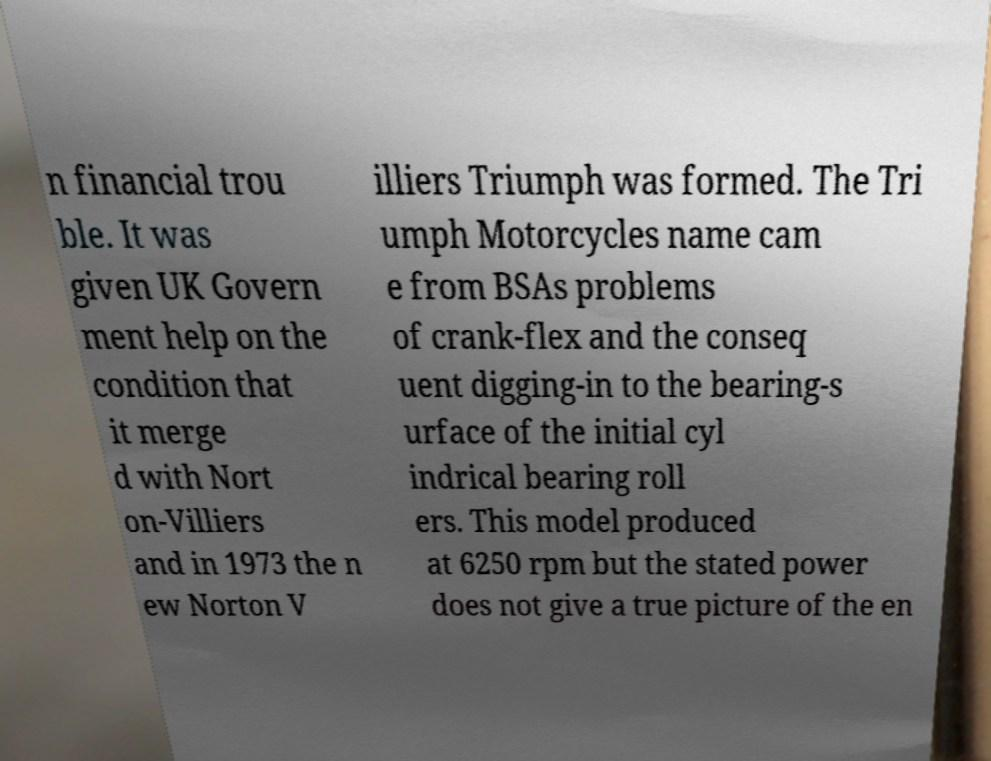Please identify and transcribe the text found in this image. n financial trou ble. It was given UK Govern ment help on the condition that it merge d with Nort on-Villiers and in 1973 the n ew Norton V illiers Triumph was formed. The Tri umph Motorcycles name cam e from BSAs problems of crank-flex and the conseq uent digging-in to the bearing-s urface of the initial cyl indrical bearing roll ers. This model produced at 6250 rpm but the stated power does not give a true picture of the en 